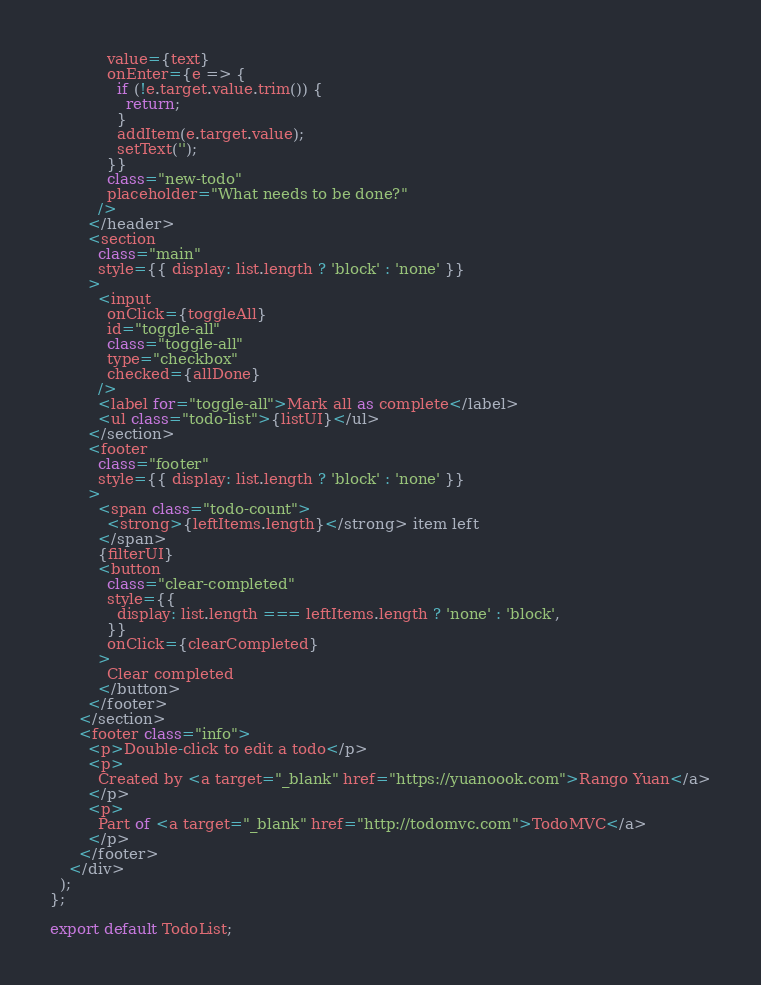<code> <loc_0><loc_0><loc_500><loc_500><_JavaScript_>            value={text}
            onEnter={e => {
              if (!e.target.value.trim()) {
                return;
              }
              addItem(e.target.value);
              setText('');
            }}
            class="new-todo"
            placeholder="What needs to be done?"
          />
        </header>
        <section
          class="main"
          style={{ display: list.length ? 'block' : 'none' }}
        >
          <input
            onClick={toggleAll}
            id="toggle-all"
            class="toggle-all"
            type="checkbox"
            checked={allDone}
          />
          <label for="toggle-all">Mark all as complete</label>
          <ul class="todo-list">{listUI}</ul>
        </section>
        <footer
          class="footer"
          style={{ display: list.length ? 'block' : 'none' }}
        >
          <span class="todo-count">
            <strong>{leftItems.length}</strong> item left
          </span>
          {filterUI}
          <button
            class="clear-completed"
            style={{
              display: list.length === leftItems.length ? 'none' : 'block',
            }}
            onClick={clearCompleted}
          >
            Clear completed
          </button>
        </footer>
      </section>
      <footer class="info">
        <p>Double-click to edit a todo</p>
        <p>
          Created by <a target="_blank" href="https://yuanoook.com">Rango Yuan</a>
        </p>
        <p>
          Part of <a target="_blank" href="http://todomvc.com">TodoMVC</a>
        </p>
      </footer>
    </div>
  );
};

export default TodoList;
</code> 